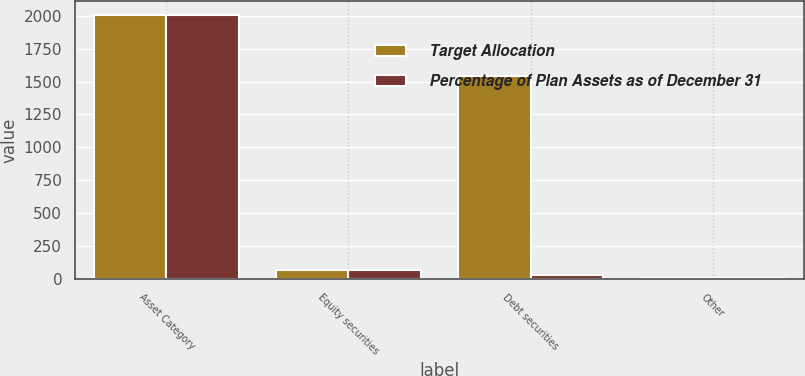Convert chart. <chart><loc_0><loc_0><loc_500><loc_500><stacked_bar_chart><ecel><fcel>Asset Category<fcel>Equity securities<fcel>Debt securities<fcel>Other<nl><fcel>Target Allocation<fcel>2009<fcel>66<fcel>1542<fcel>5<nl><fcel>Percentage of Plan Assets as of December 31<fcel>2008<fcel>66<fcel>32<fcel>2<nl></chart> 